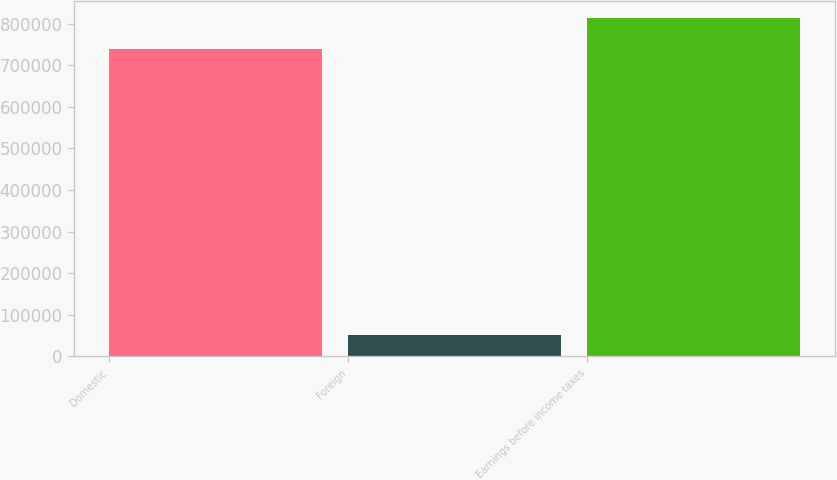<chart> <loc_0><loc_0><loc_500><loc_500><bar_chart><fcel>Domestic<fcel>Foreign<fcel>Earnings before income taxes<nl><fcel>739383<fcel>50346<fcel>813321<nl></chart> 